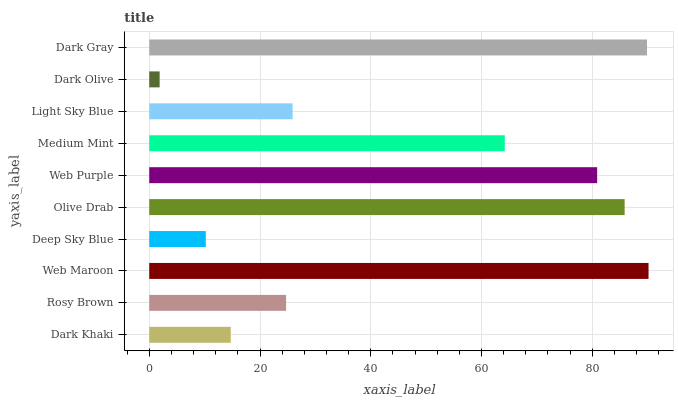Is Dark Olive the minimum?
Answer yes or no. Yes. Is Web Maroon the maximum?
Answer yes or no. Yes. Is Rosy Brown the minimum?
Answer yes or no. No. Is Rosy Brown the maximum?
Answer yes or no. No. Is Rosy Brown greater than Dark Khaki?
Answer yes or no. Yes. Is Dark Khaki less than Rosy Brown?
Answer yes or no. Yes. Is Dark Khaki greater than Rosy Brown?
Answer yes or no. No. Is Rosy Brown less than Dark Khaki?
Answer yes or no. No. Is Medium Mint the high median?
Answer yes or no. Yes. Is Light Sky Blue the low median?
Answer yes or no. Yes. Is Dark Olive the high median?
Answer yes or no. No. Is Deep Sky Blue the low median?
Answer yes or no. No. 